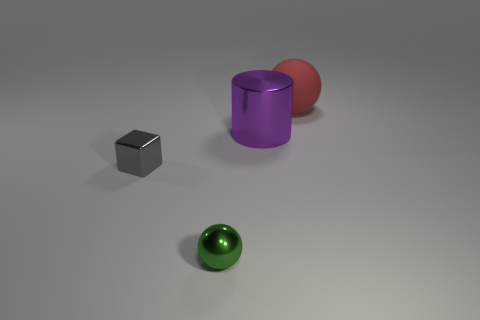Is there any other thing that is the same material as the red sphere?
Provide a succinct answer. No. There is a thing that is both behind the tiny gray metallic thing and left of the red rubber object; what material is it?
Your answer should be very brief. Metal. There is another small object that is the same shape as the red rubber thing; what color is it?
Your answer should be compact. Green. Do the metal sphere and the red thing have the same size?
Offer a very short reply. No. There is a small object that is behind the sphere that is left of the red matte object; what is its material?
Ensure brevity in your answer.  Metal. Is there a large cyan object of the same shape as the red matte object?
Ensure brevity in your answer.  No. What is the shape of the gray shiny object?
Provide a succinct answer. Cube. What is the sphere that is on the right side of the big thing in front of the sphere that is behind the small gray metal object made of?
Provide a succinct answer. Rubber. Are there more shiny objects that are to the left of the small green metallic ball than big cyan matte cylinders?
Offer a very short reply. Yes. What is the material of the green object that is the same size as the cube?
Your answer should be very brief. Metal. 